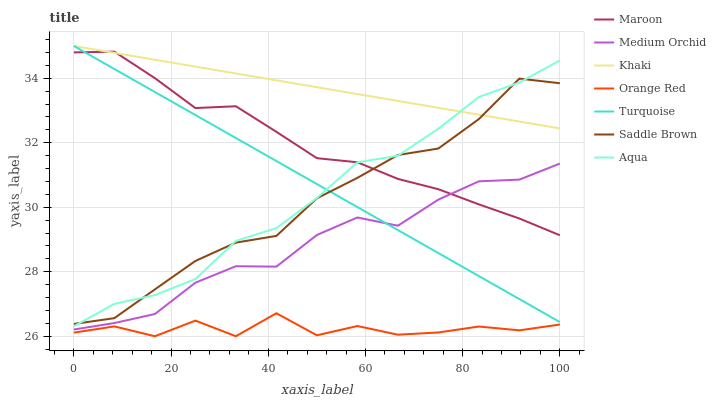Does Orange Red have the minimum area under the curve?
Answer yes or no. Yes. Does Khaki have the maximum area under the curve?
Answer yes or no. Yes. Does Medium Orchid have the minimum area under the curve?
Answer yes or no. No. Does Medium Orchid have the maximum area under the curve?
Answer yes or no. No. Is Turquoise the smoothest?
Answer yes or no. Yes. Is Orange Red the roughest?
Answer yes or no. Yes. Is Khaki the smoothest?
Answer yes or no. No. Is Khaki the roughest?
Answer yes or no. No. Does Orange Red have the lowest value?
Answer yes or no. Yes. Does Medium Orchid have the lowest value?
Answer yes or no. No. Does Khaki have the highest value?
Answer yes or no. Yes. Does Medium Orchid have the highest value?
Answer yes or no. No. Is Orange Red less than Saddle Brown?
Answer yes or no. Yes. Is Aqua greater than Medium Orchid?
Answer yes or no. Yes. Does Medium Orchid intersect Turquoise?
Answer yes or no. Yes. Is Medium Orchid less than Turquoise?
Answer yes or no. No. Is Medium Orchid greater than Turquoise?
Answer yes or no. No. Does Orange Red intersect Saddle Brown?
Answer yes or no. No. 